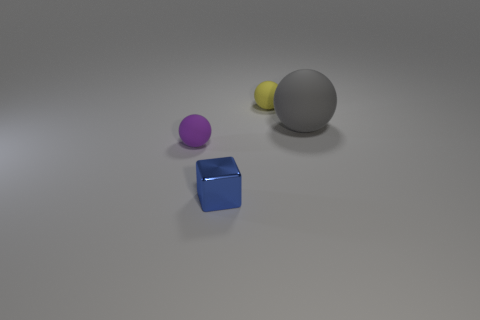There is a small matte ball that is on the left side of the tiny yellow matte thing; what number of things are left of it? 0 